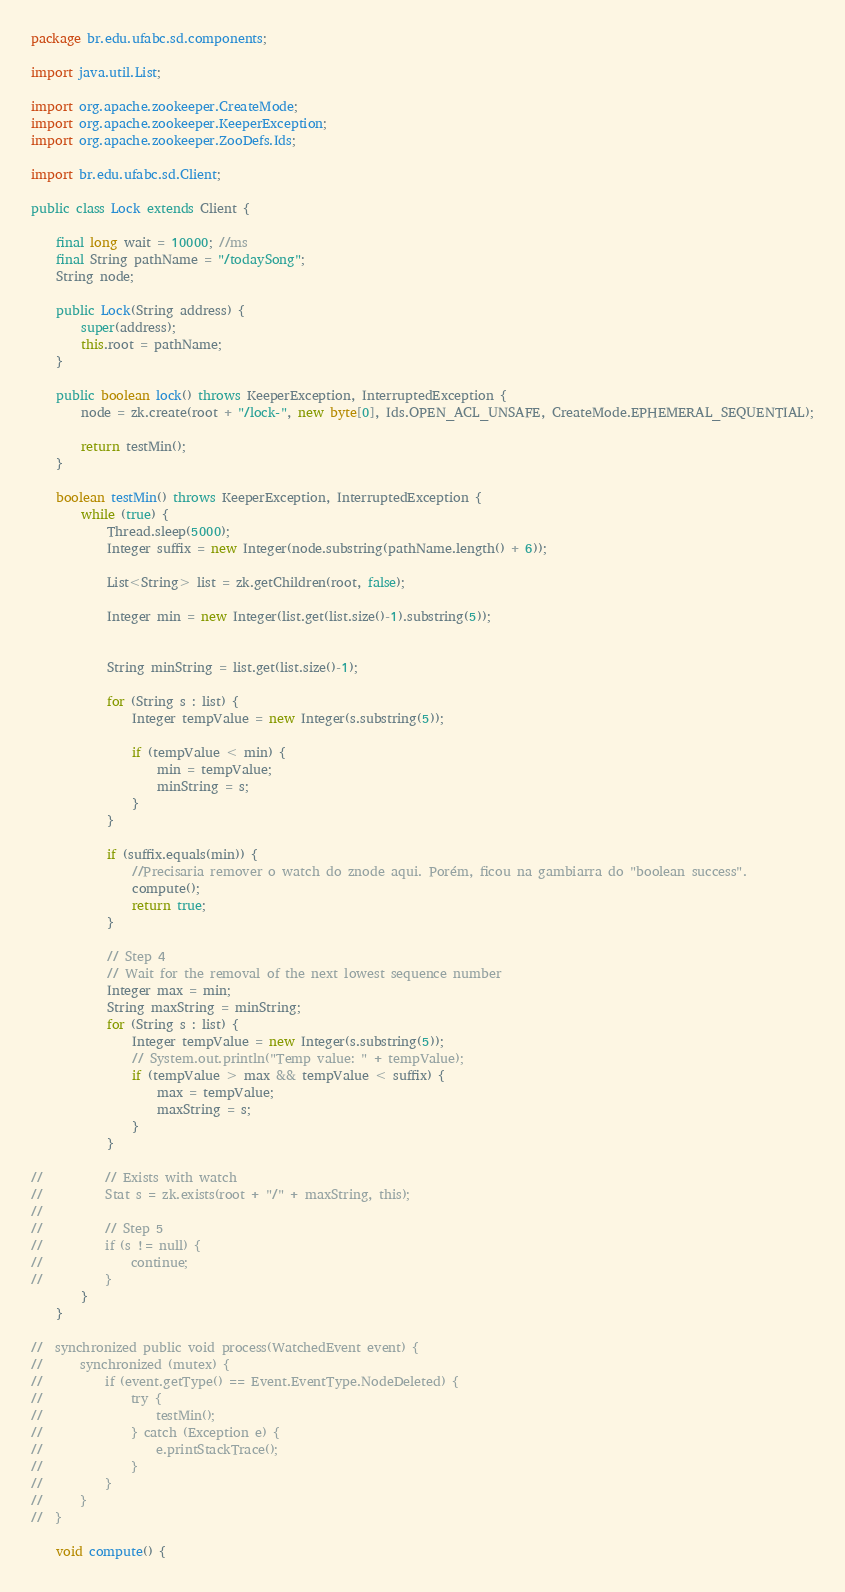Convert code to text. <code><loc_0><loc_0><loc_500><loc_500><_Java_>package br.edu.ufabc.sd.components;

import java.util.List;

import org.apache.zookeeper.CreateMode;
import org.apache.zookeeper.KeeperException;
import org.apache.zookeeper.ZooDefs.Ids;

import br.edu.ufabc.sd.Client;

public class Lock extends Client {

	final long wait = 10000; //ms
	final String pathName = "/todaySong";
	String node;

	public Lock(String address) {
		super(address);
		this.root = pathName;
	}

	public boolean lock() throws KeeperException, InterruptedException {
		node = zk.create(root + "/lock-", new byte[0], Ids.OPEN_ACL_UNSAFE, CreateMode.EPHEMERAL_SEQUENTIAL);
		
		return testMin();
	}

	boolean testMin() throws KeeperException, InterruptedException {
		while (true) {
			Thread.sleep(5000);
			Integer suffix = new Integer(node.substring(pathName.length() + 6));
			
			List<String> list = zk.getChildren(root, false);
			
			Integer min = new Integer(list.get(list.size()-1).substring(5));
			
			
			String minString = list.get(list.size()-1);
			
			for (String s : list) {
				Integer tempValue = new Integer(s.substring(5));
				
				if (tempValue < min) {
					min = tempValue;
					minString = s;
				}
			}
			
			if (suffix.equals(min)) {
				//Precisaria remover o watch do znode aqui. Porém, ficou na gambiarra do "boolean success".
				compute();
				return true;
			}
			
			// Step 4
			// Wait for the removal of the next lowest sequence number
			Integer max = min;
			String maxString = minString;
			for (String s : list) {
				Integer tempValue = new Integer(s.substring(5));
				// System.out.println("Temp value: " + tempValue);
				if (tempValue > max && tempValue < suffix) {
					max = tempValue;
					maxString = s;
				}
			}
			
//			// Exists with watch
//			Stat s = zk.exists(root + "/" + maxString, this);
//			
//			// Step 5
//			if (s != null) {
//				continue;
//			}
		}
	}

//	synchronized public void process(WatchedEvent event) {
//		synchronized (mutex) {
//			if (event.getType() == Event.EventType.NodeDeleted) {
//				try {
//					testMin();
//				} catch (Exception e) {
//					e.printStackTrace();
//				}
//			}
//		}
//	}

	void compute() {</code> 